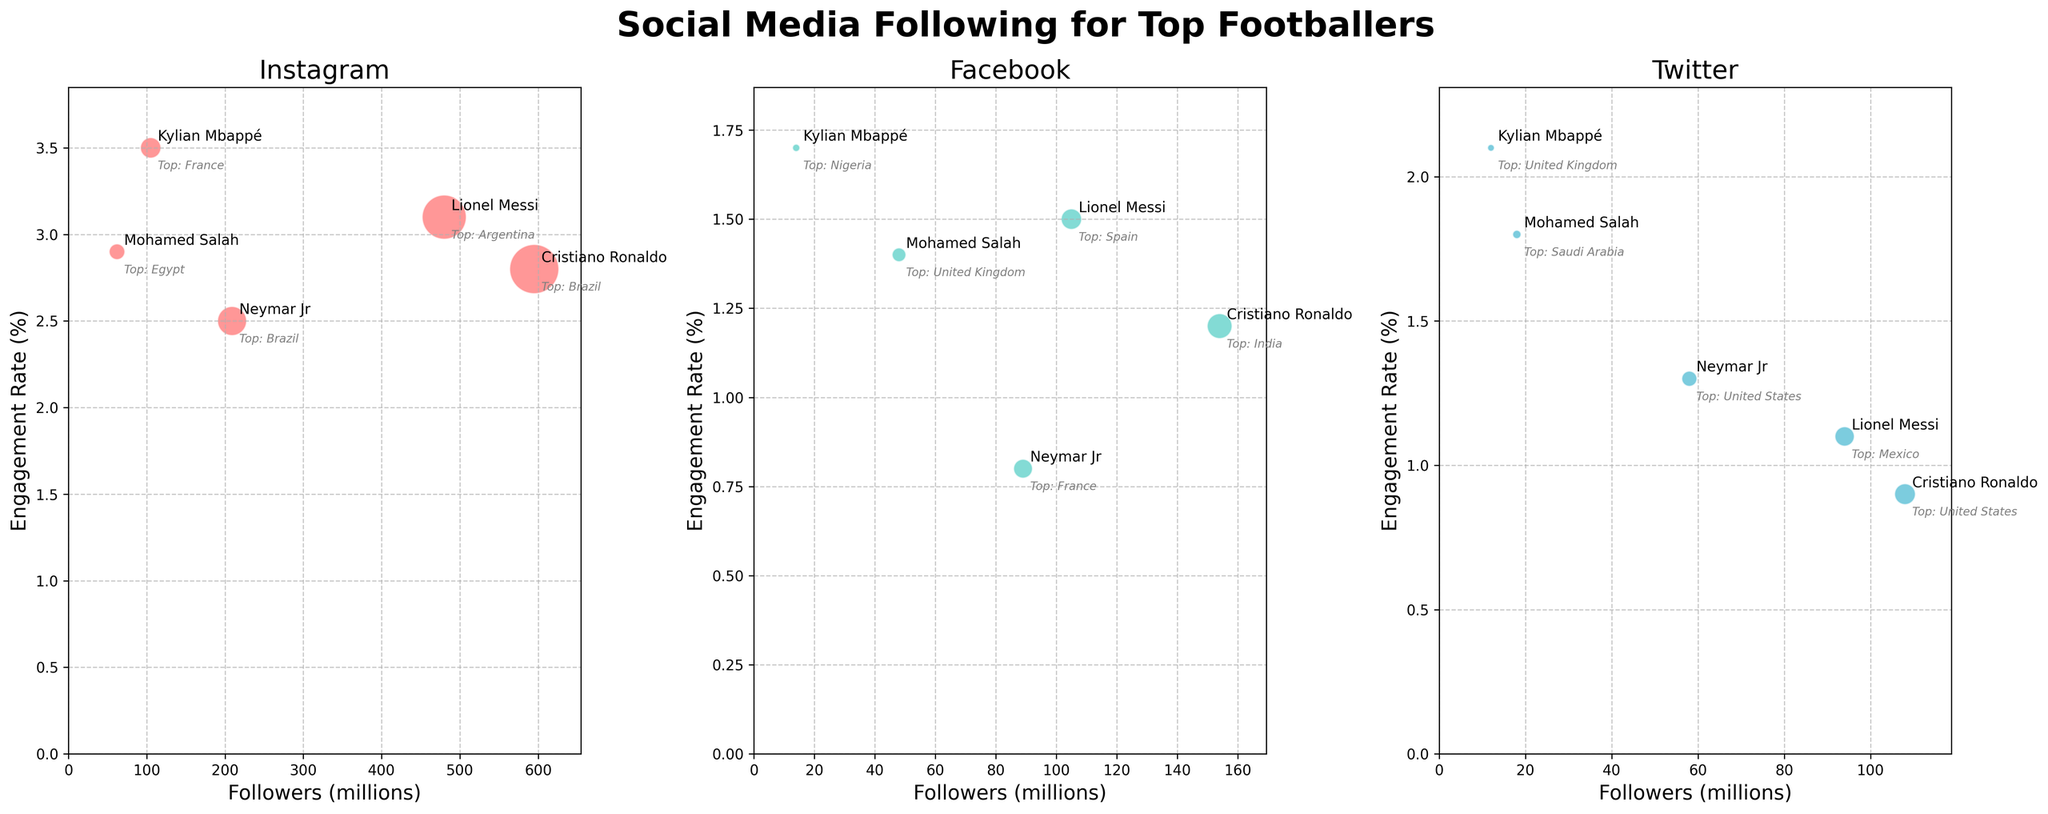Which footballer has the largest social media following on Instagram? The largest bubble on the Instagram subplot represents Cristiano Ronaldo, who has 595 million followers.
Answer: Cristiano Ronaldo What is the title of this figure? The title is positioned at the top of the figure and reads "Social Media Following for Top Footballers".
Answer: Social Media Following for Top Footballers How many followers does Neymar Jr. have on Facebook, and what is his engagement rate there? Locate Neymar Jr. on the Facebook subplot and read the "Followers" and "Engagement Rate" values. Neymar Jr. has 89 million followers and an engagement rate of 0.8%.
Answer: 89 million followers, 0.8% Which platform has higher engagement rates for Lionel Messi, Instagram or Facebook? Compare the bubbles representing Lionel Messi on the Instagram and Facebook subplots. His engagement rate on Instagram is 3.1%, while on Facebook it's 1.5%.
Answer: Instagram Which footballer has the highest engagement rate on Instagram? Look for the bubble on the Instagram subplot with the highest vertical position. Kylian Mbappé, represented by the highest bubble, has an engagement rate of 3.5%.
Answer: Kylian Mbappé List the top geographic locations for Cristiano Ronaldo's social media following across all platforms. Annotate the bubbles labeled "Cristiano Ronaldo" on each subplot and note the top geographic locations: Instagram - Brazil, Facebook - India, Twitter - United States.
Answer: Brazil, India, United States Compare the number of followers Mohamed Salah has on Instagram and Twitter. Which platform has more followers? Identify Mohamed Salah's bubbles on Instagram and Twitter subplots. He has 62 million followers on Instagram and 18 million on Twitter.
Answer: Instagram Calculate the average engagement rate for Kylian Mbappé across all platforms. Sum up Kylian Mbappé's engagement rates on Instagram (3.5%), Facebook (1.7%), and Twitter (2.1%). Then divide by 3: (3.5 + 1.7 + 2.1) / 3 ≈ 2.43%.
Answer: ~2.43% Which platform shows the highest engagement rate for Neymar Jr.? Compare Neymar Jr.'s engagement rates on Instagram, Facebook, and Twitter. His highest engagement rate is on Instagram at 2.5%.
Answer: Instagram 